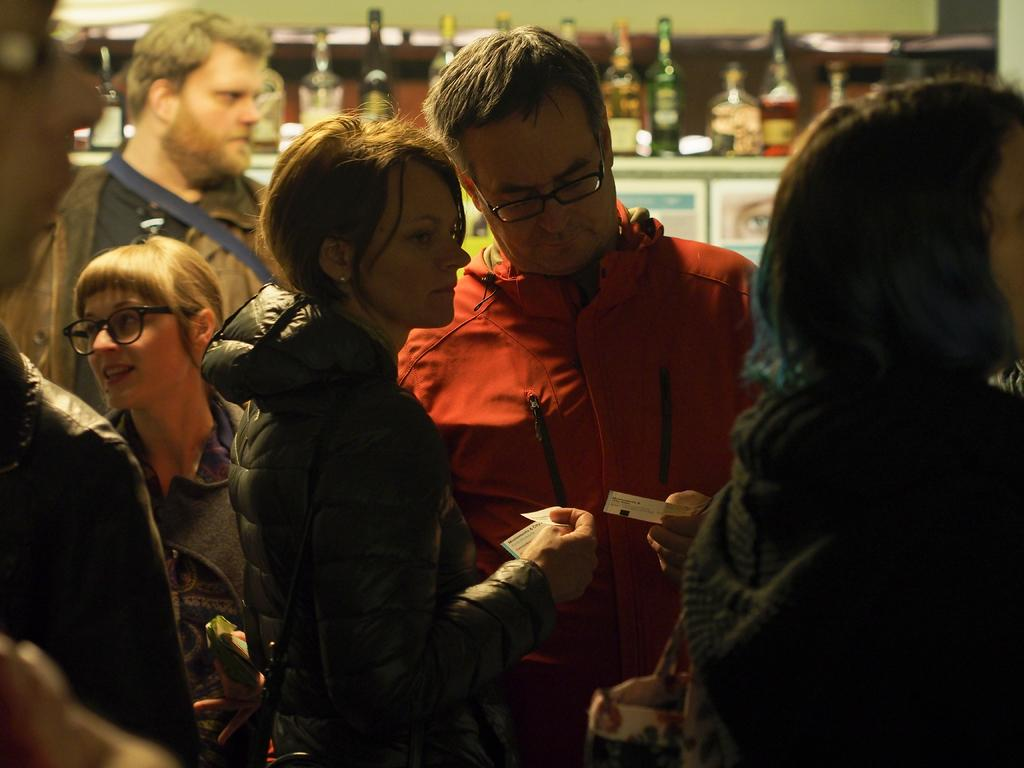Who or what is present in the image? There are people in the image. What objects can be seen near the people? There are bottles on an object in the image. What type of structure is visible in the image? There is a wall visible in the image. What type of growth can be seen on the wall in the image? There is no growth visible on the wall in the image. Can you see any stars in the image? There are no stars visible in the image. 